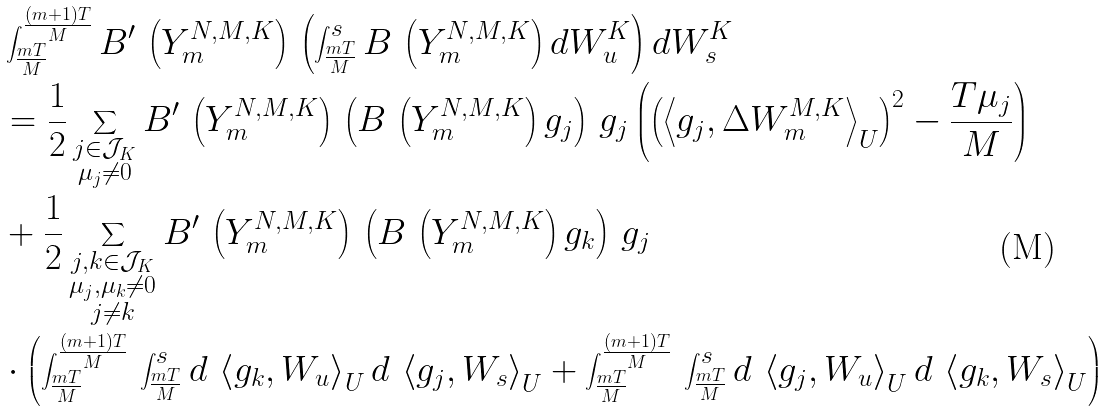<formula> <loc_0><loc_0><loc_500><loc_500>& \int _ { \frac { m T } { M } } ^ { \frac { ( m + 1 ) T } { M } } B ^ { \prime } \, \left ( Y _ { m } ^ { N , M , K } \right ) \, \left ( \int _ { \frac { m T } { M } } ^ { s } B \, \left ( Y _ { m } ^ { N , M , K } \right ) d W _ { u } ^ { K } \right ) d W _ { s } ^ { K } \\ & = \frac { 1 } { 2 } \sum _ { \substack { j \in \mathcal { J } _ { K } \\ \mu _ { j } \neq 0 } } B ^ { \prime } \, \left ( Y _ { m } ^ { N , M , K } \right ) \, \left ( B \, \left ( Y _ { m } ^ { N , M , K } \right ) g _ { j } \right ) \, g _ { j } \left ( \left ( \left < g _ { j } , \Delta W _ { m } ^ { M , K } \right > _ { U } \right ) ^ { 2 } - \frac { T \mu _ { j } } { M } \right ) \\ & + \frac { 1 } { 2 } \sum _ { \substack { j , k \in \mathcal { J } _ { K } \\ \mu _ { j } , \mu _ { k } \neq 0 \\ j \neq k } } B ^ { \prime } \, \left ( Y _ { m } ^ { N , M , K } \right ) \, \left ( B \, \left ( Y _ { m } ^ { N , M , K } \right ) g _ { k } \right ) \, g _ { j } \\ & \cdot \left ( \int _ { \frac { m T } { M } } ^ { \frac { ( m + 1 ) T } { M } } \, \int _ { \frac { m T } { M } } ^ { s } d \, \left < g _ { k } , W _ { u } \right > _ { U } d \, \left < g _ { j } , W _ { s } \right > _ { U } + \int _ { \frac { m T } { M } } ^ { \frac { ( m + 1 ) T } { M } } \, \int _ { \frac { m T } { M } } ^ { s } d \, \left < g _ { j } , W _ { u } \right > _ { U } d \, \left < g _ { k } , W _ { s } \right > _ { U } \right )</formula> 